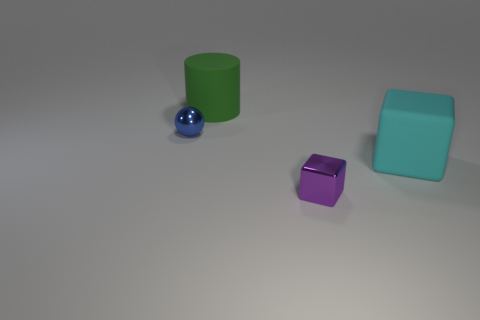Add 4 small blue metallic spheres. How many objects exist? 8 Subtract all cylinders. How many objects are left? 3 Subtract 0 gray cubes. How many objects are left? 4 Subtract all small objects. Subtract all shiny cubes. How many objects are left? 1 Add 3 shiny cubes. How many shiny cubes are left? 4 Add 1 red metallic blocks. How many red metallic blocks exist? 1 